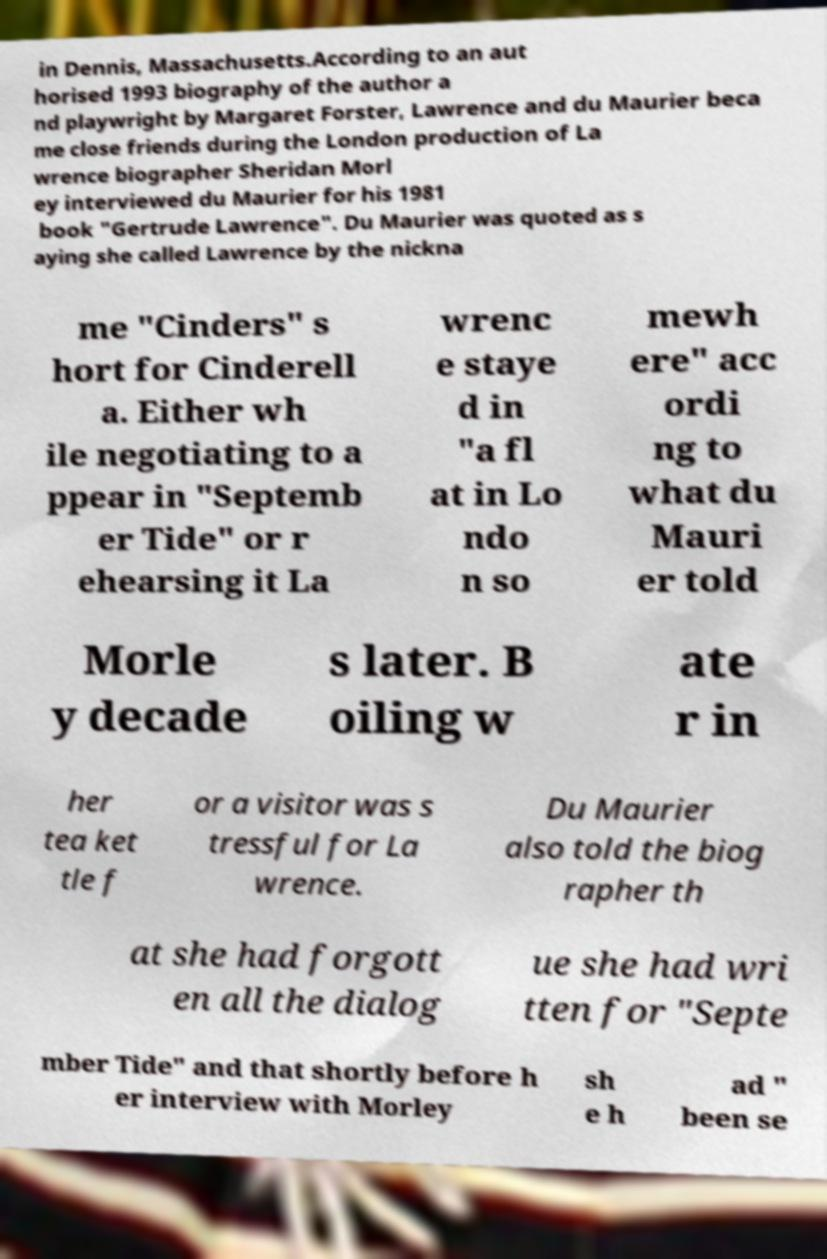Please read and relay the text visible in this image. What does it say? in Dennis, Massachusetts.According to an aut horised 1993 biography of the author a nd playwright by Margaret Forster, Lawrence and du Maurier beca me close friends during the London production of La wrence biographer Sheridan Morl ey interviewed du Maurier for his 1981 book "Gertrude Lawrence". Du Maurier was quoted as s aying she called Lawrence by the nickna me "Cinders" s hort for Cinderell a. Either wh ile negotiating to a ppear in "Septemb er Tide" or r ehearsing it La wrenc e staye d in "a fl at in Lo ndo n so mewh ere" acc ordi ng to what du Mauri er told Morle y decade s later. B oiling w ate r in her tea ket tle f or a visitor was s tressful for La wrence. Du Maurier also told the biog rapher th at she had forgott en all the dialog ue she had wri tten for "Septe mber Tide" and that shortly before h er interview with Morley sh e h ad " been se 